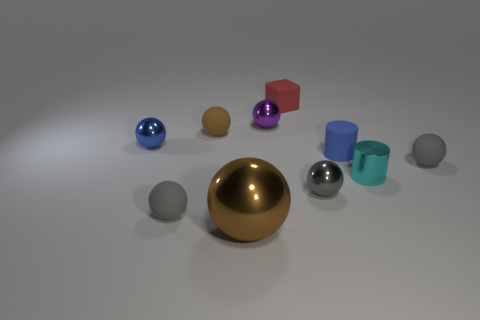Subtract all yellow cubes. How many gray balls are left? 3 Subtract 1 balls. How many balls are left? 6 Subtract all purple spheres. How many spheres are left? 6 Subtract all blue balls. How many balls are left? 6 Subtract all red spheres. Subtract all gray cubes. How many spheres are left? 7 Subtract all balls. How many objects are left? 3 Add 4 matte things. How many matte things are left? 9 Add 5 gray matte balls. How many gray matte balls exist? 7 Subtract 0 brown cubes. How many objects are left? 10 Subtract all big cyan blocks. Subtract all tiny blue matte cylinders. How many objects are left? 9 